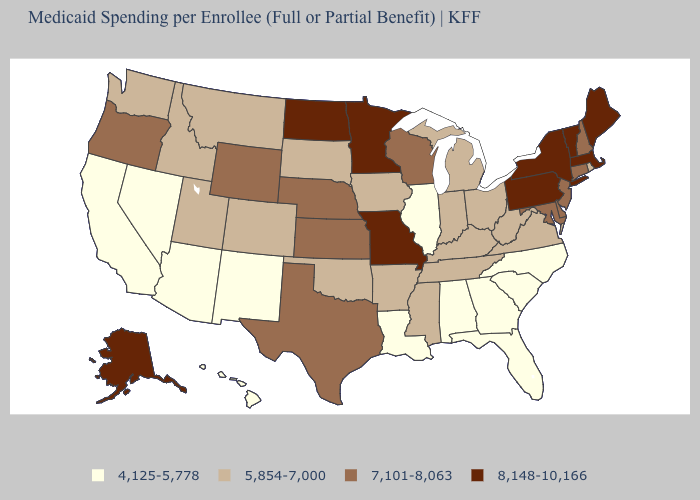Among the states that border Illinois , which have the lowest value?
Be succinct. Indiana, Iowa, Kentucky. Among the states that border New Jersey , which have the highest value?
Write a very short answer. New York, Pennsylvania. What is the value of Indiana?
Quick response, please. 5,854-7,000. Which states have the highest value in the USA?
Give a very brief answer. Alaska, Maine, Massachusetts, Minnesota, Missouri, New York, North Dakota, Pennsylvania, Vermont. What is the value of Alabama?
Write a very short answer. 4,125-5,778. What is the lowest value in states that border Washington?
Answer briefly. 5,854-7,000. What is the value of Idaho?
Short answer required. 5,854-7,000. Name the states that have a value in the range 8,148-10,166?
Keep it brief. Alaska, Maine, Massachusetts, Minnesota, Missouri, New York, North Dakota, Pennsylvania, Vermont. Name the states that have a value in the range 7,101-8,063?
Concise answer only. Connecticut, Delaware, Kansas, Maryland, Nebraska, New Hampshire, New Jersey, Oregon, Texas, Wisconsin, Wyoming. What is the value of Florida?
Short answer required. 4,125-5,778. What is the value of South Dakota?
Answer briefly. 5,854-7,000. Name the states that have a value in the range 5,854-7,000?
Give a very brief answer. Arkansas, Colorado, Idaho, Indiana, Iowa, Kentucky, Michigan, Mississippi, Montana, Ohio, Oklahoma, Rhode Island, South Dakota, Tennessee, Utah, Virginia, Washington, West Virginia. Does Delaware have the highest value in the USA?
Quick response, please. No. What is the lowest value in the South?
Concise answer only. 4,125-5,778. Among the states that border Rhode Island , does Connecticut have the highest value?
Concise answer only. No. 